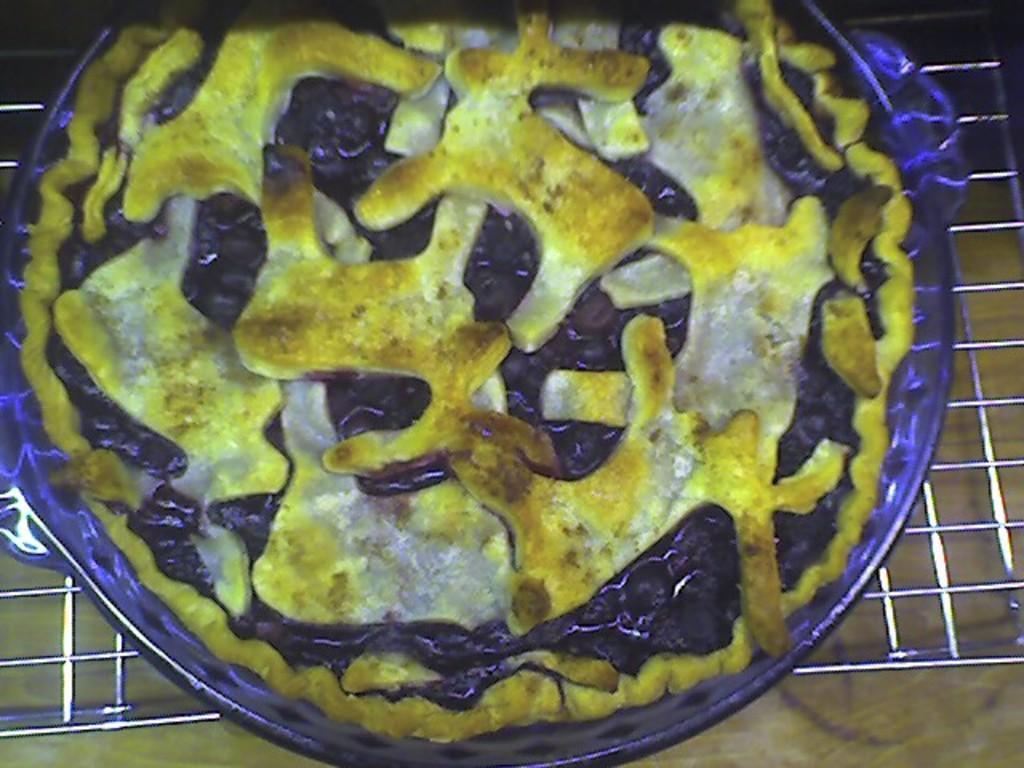How would you summarize this image in a sentence or two? In this image there is a pizza on the pan which is placed on the grill. 